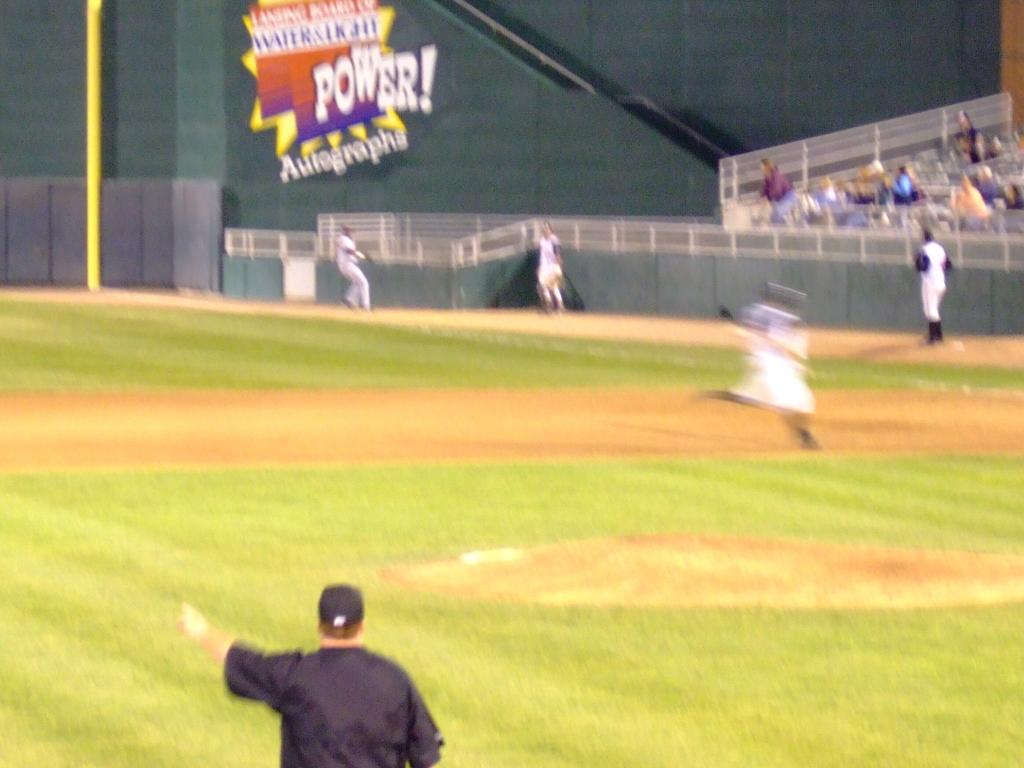<image>
Share a concise interpretation of the image provided. A shot of a baseball field with A Power! Autographs advertisement on the outfield wall 